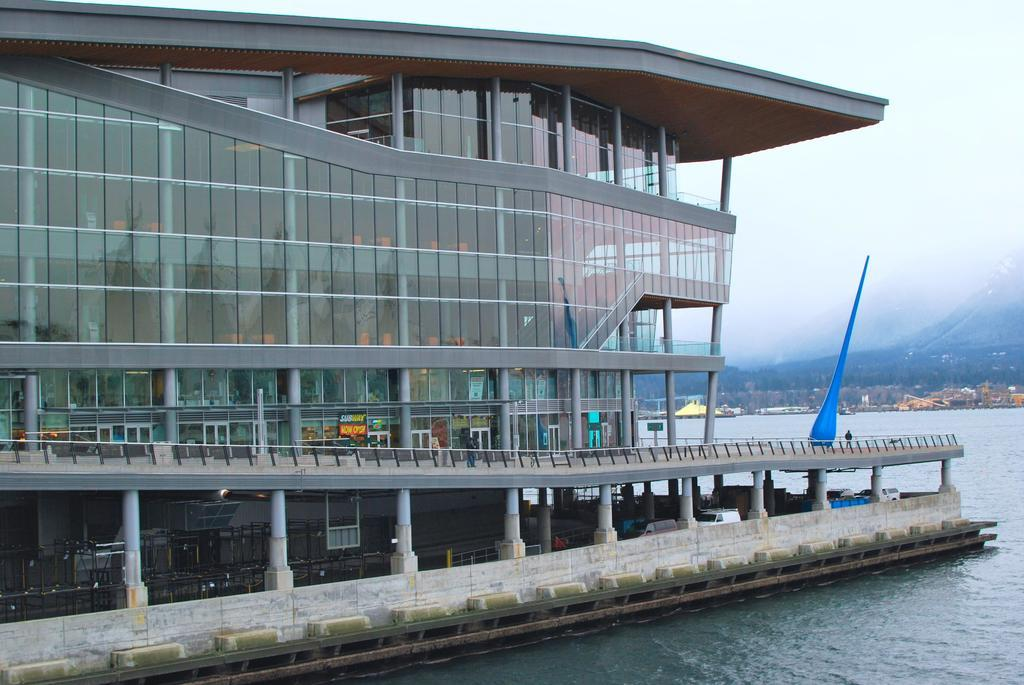What type of building is shown in the image? There is a glass building in the image. What structures can be seen surrounding the building? There are fences and pillars in the image. What mode of transportation is present in the image? There are vehicles in the image. What natural feature can be seen in the background? There are mountains visible in the image. What is the weather like in the image? There is fog on the mountains, suggesting a cool or damp environment. How many mice are playing on the blue color pole in the image? There are no mice present in the image; the blue color pole is the only object mentioned that is not in the image. 